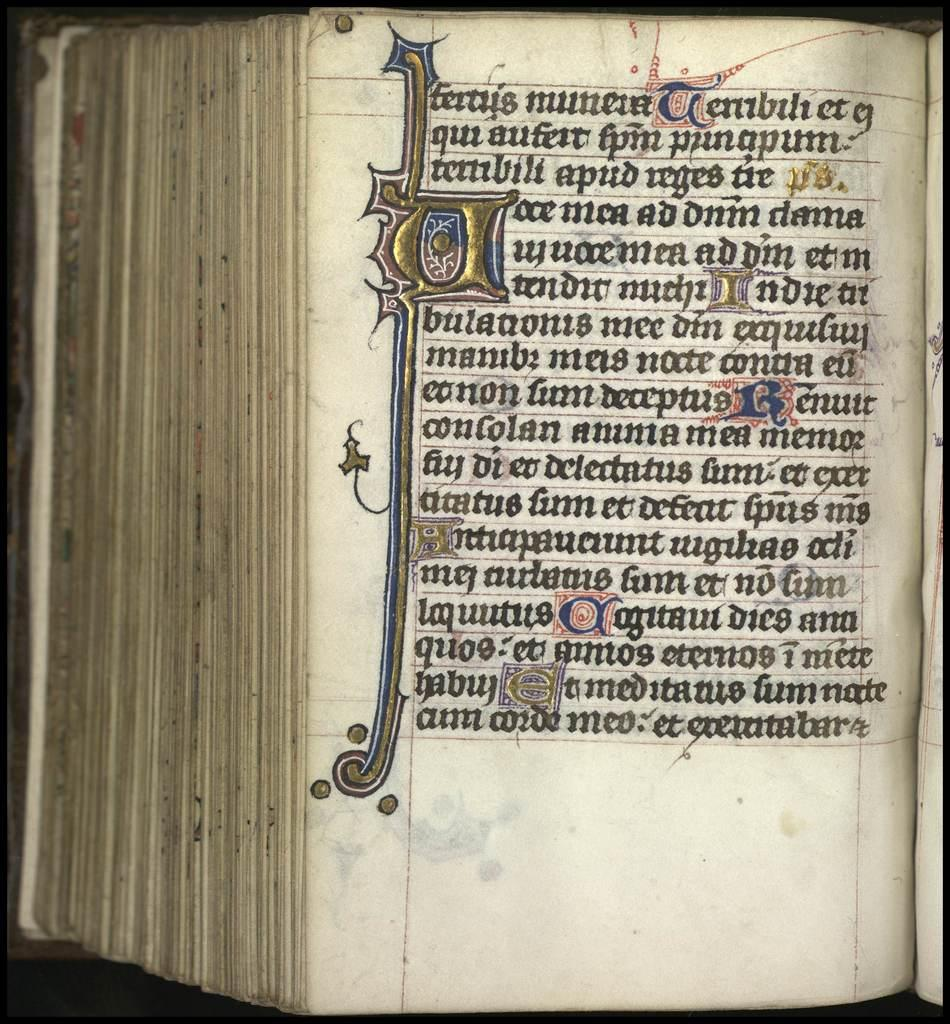<image>
Render a clear and concise summary of the photo. The first word of the second line of an open book is qui. 